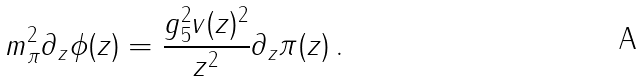Convert formula to latex. <formula><loc_0><loc_0><loc_500><loc_500>m _ { \pi } ^ { 2 } \partial _ { z } \phi ( z ) = \frac { g ^ { 2 } _ { 5 } v ( z ) ^ { 2 } } { z ^ { 2 } } \partial _ { z } \pi ( z ) \, .</formula> 